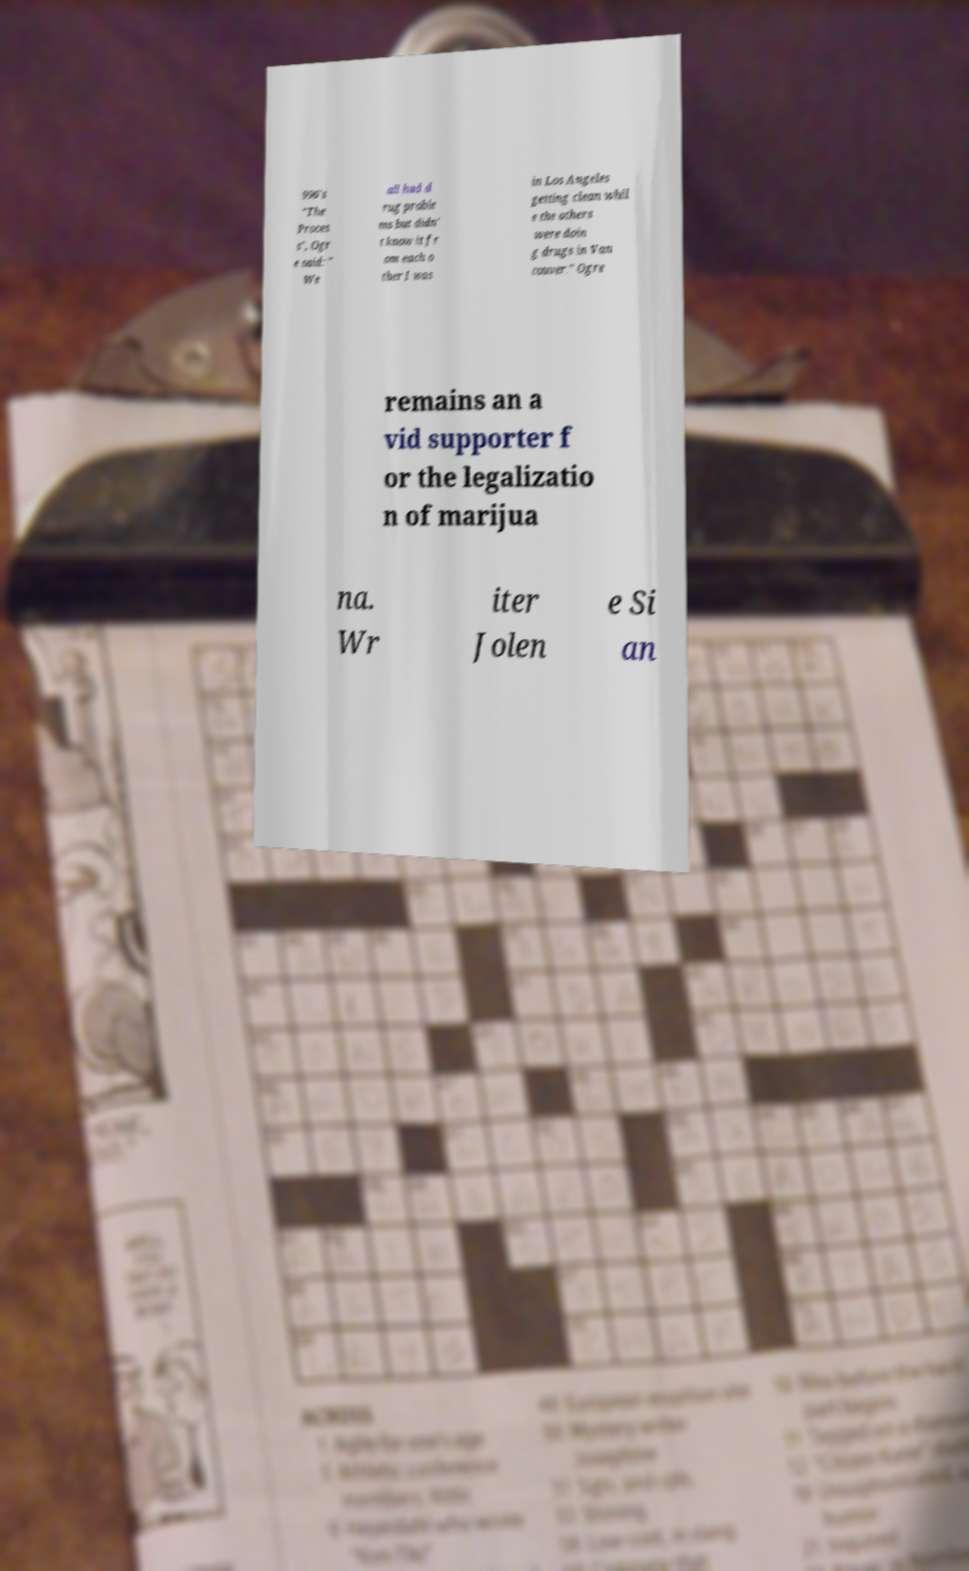Can you accurately transcribe the text from the provided image for me? 996's "The Proces s", Ogr e said: " We all had d rug proble ms but didn' t know it fr om each o ther I was in Los Angeles getting clean whil e the others were doin g drugs in Van couver." Ogre remains an a vid supporter f or the legalizatio n of marijua na. Wr iter Jolen e Si an 